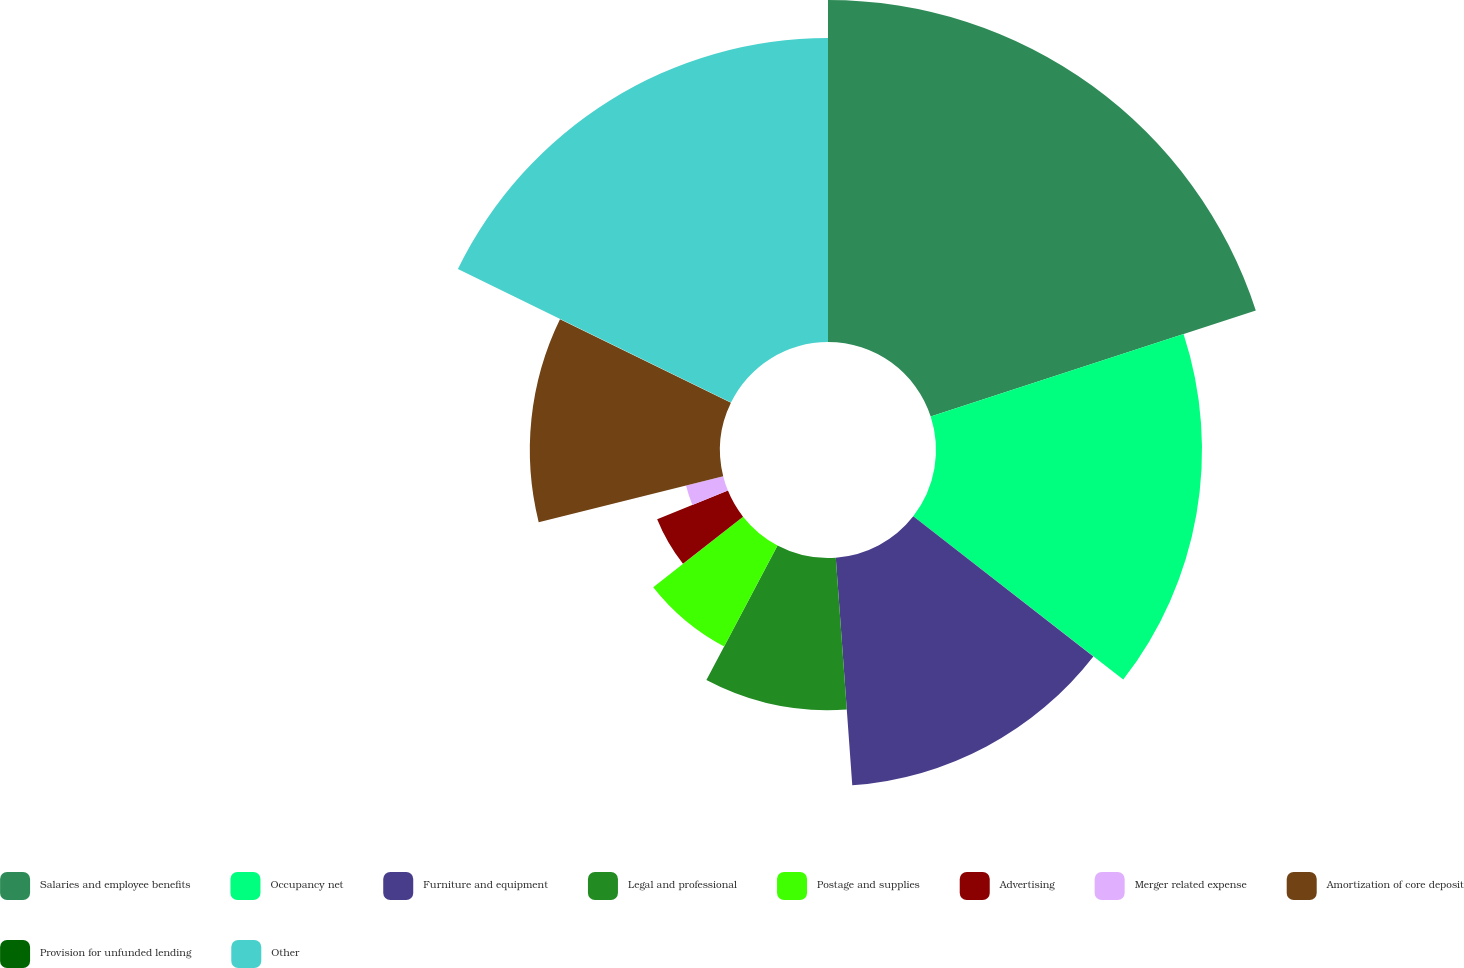Convert chart. <chart><loc_0><loc_0><loc_500><loc_500><pie_chart><fcel>Salaries and employee benefits<fcel>Occupancy net<fcel>Furniture and equipment<fcel>Legal and professional<fcel>Postage and supplies<fcel>Advertising<fcel>Merger related expense<fcel>Amortization of core deposit<fcel>Provision for unfunded lending<fcel>Other<nl><fcel>19.98%<fcel>15.54%<fcel>13.33%<fcel>8.89%<fcel>6.67%<fcel>4.46%<fcel>2.24%<fcel>11.11%<fcel>0.02%<fcel>17.76%<nl></chart> 